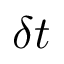Convert formula to latex. <formula><loc_0><loc_0><loc_500><loc_500>\delta t</formula> 